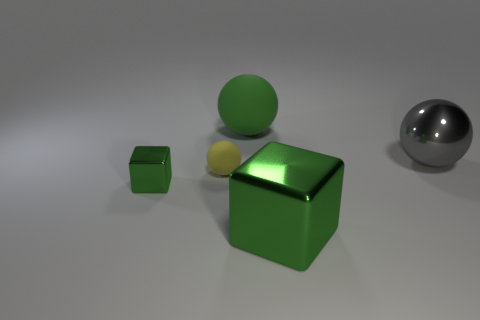Subtract all rubber spheres. How many spheres are left? 1 Add 3 small brown rubber cubes. How many objects exist? 8 Subtract all gray balls. How many balls are left? 2 Subtract 0 red cylinders. How many objects are left? 5 Subtract all cubes. How many objects are left? 3 Subtract 2 spheres. How many spheres are left? 1 Subtract all blue balls. Subtract all gray cylinders. How many balls are left? 3 Subtract all large green shiny things. Subtract all spheres. How many objects are left? 1 Add 5 small metal cubes. How many small metal cubes are left? 6 Add 5 large green blocks. How many large green blocks exist? 6 